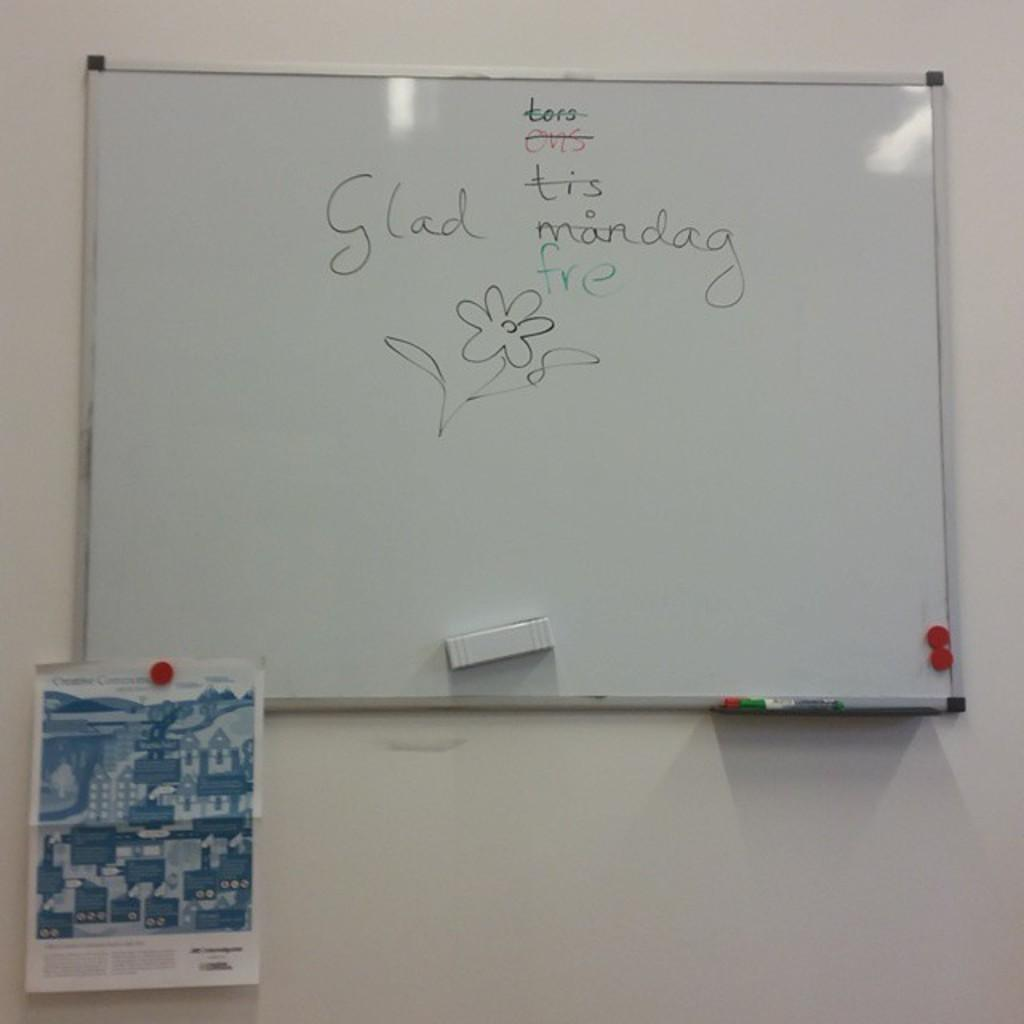<image>
Share a concise interpretation of the image provided. Someone has written the word "glad" near a flower on a whiteboard. 